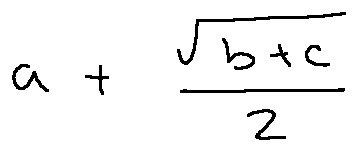<formula> <loc_0><loc_0><loc_500><loc_500>a + \frac { \sqrt { b + c } } { 2 }</formula> 